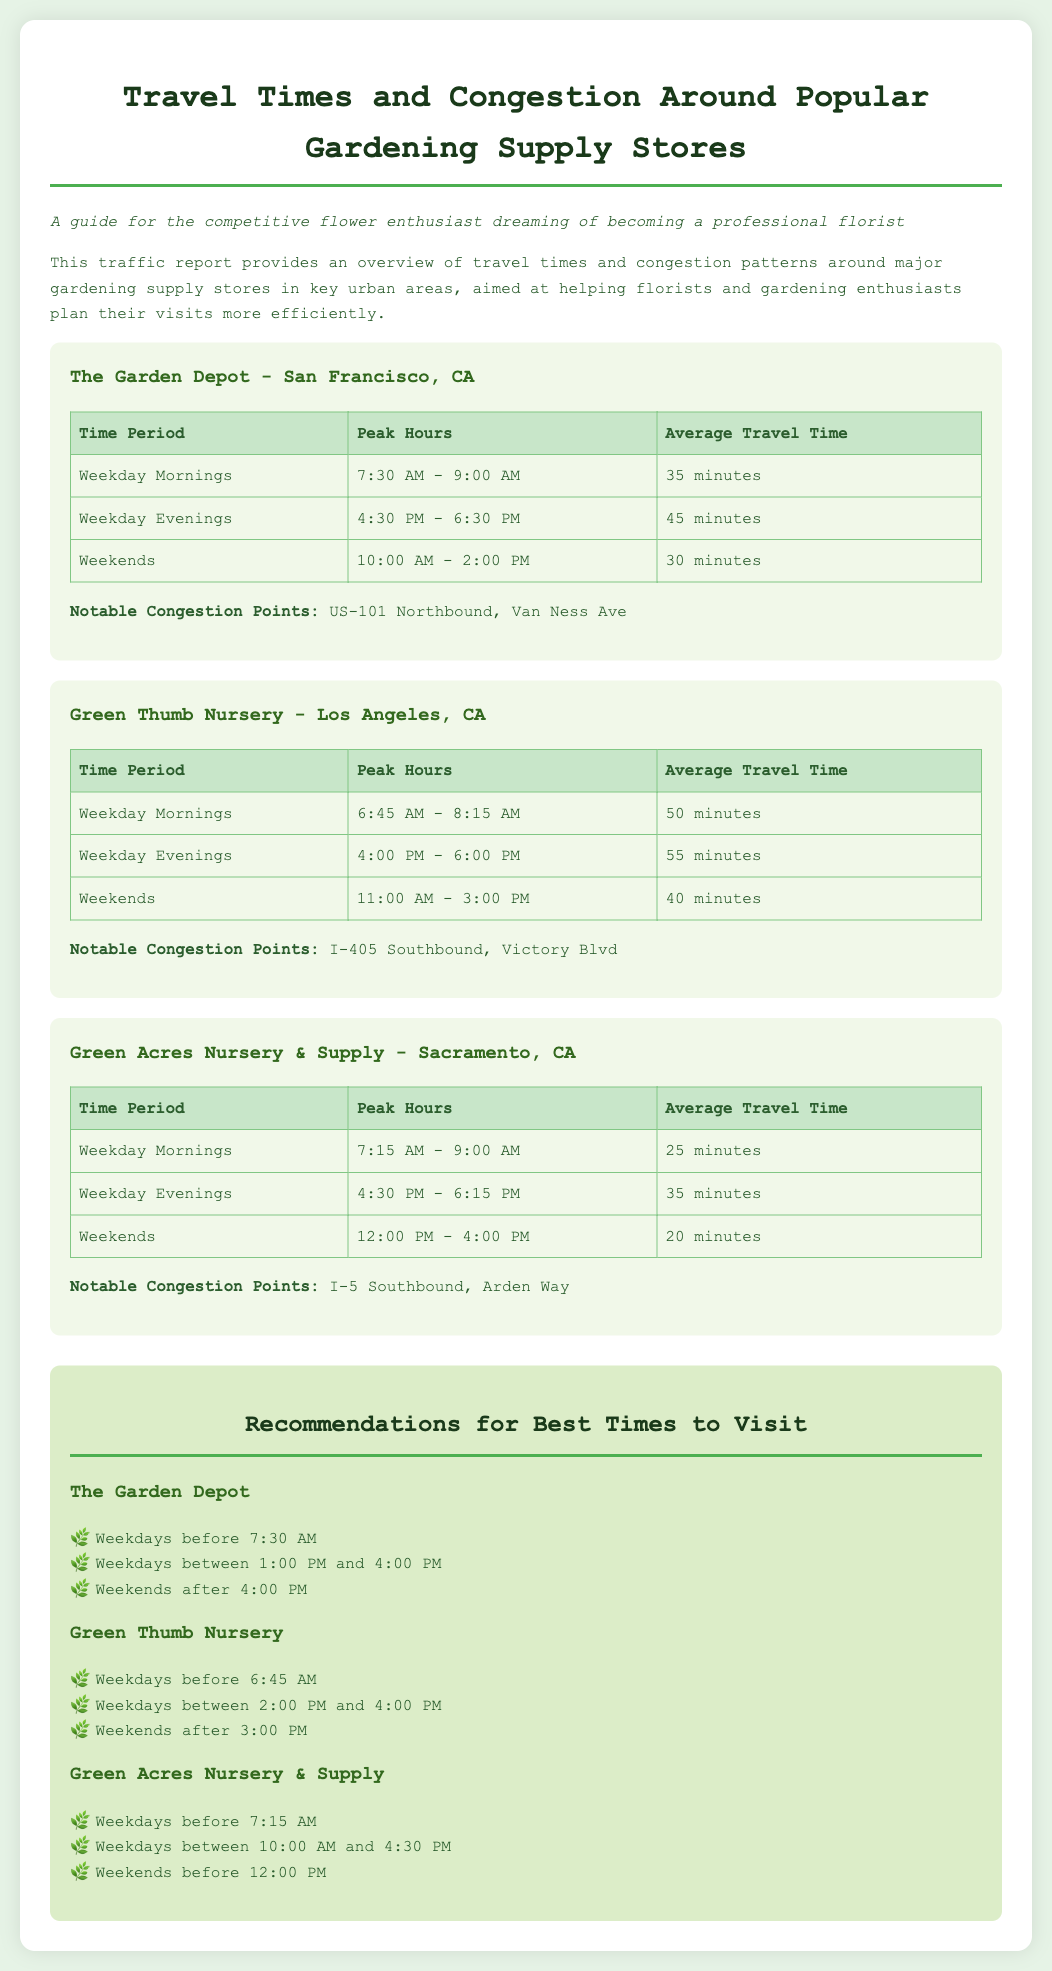What is the average travel time for The Garden Depot on weekday mornings? The average travel time for The Garden Depot on weekday mornings is 35 minutes, as stated in the table.
Answer: 35 minutes What are the peak hours for Green Thumb Nursery on weekends? The peak hours for Green Thumb Nursery on weekends are 11:00 AM - 3:00 PM, mentioned in the table.
Answer: 11:00 AM - 3:00 PM Which notable congestion point is associated with Green Acres Nursery & Supply? The notable congestion point associated with Green Acres Nursery & Supply is I-5 Southbound, as listed in the document.
Answer: I-5 Southbound What is the recommended time to visit The Garden Depot on weekdays? The recommended times to visit The Garden Depot on weekdays include before 7:30 AM, as outlined in the recommendations section.
Answer: Before 7:30 AM What is the average travel time for Green Thumb Nursery on weekday evenings? The average travel time for Green Thumb Nursery on weekday evenings is 55 minutes, as indicated in the table.
Answer: 55 minutes Which gardening supply store has the shortest average travel time on weekends? Green Acres Nursery & Supply has the shortest average travel time on weekends at 20 minutes, according to the data presented.
Answer: 20 minutes What time period shows the heaviest congestion at The Garden Depot? The heaviest congestion at The Garden Depot occurs during Weekday Evenings, with 45 minutes of average travel time.
Answer: Weekday Evenings What is the lowest average travel time recorded for Green Thumb Nursery? The lowest average travel time recorded for Green Thumb Nursery is 40 minutes on weekends, derived from the provided data.
Answer: 40 minutes 